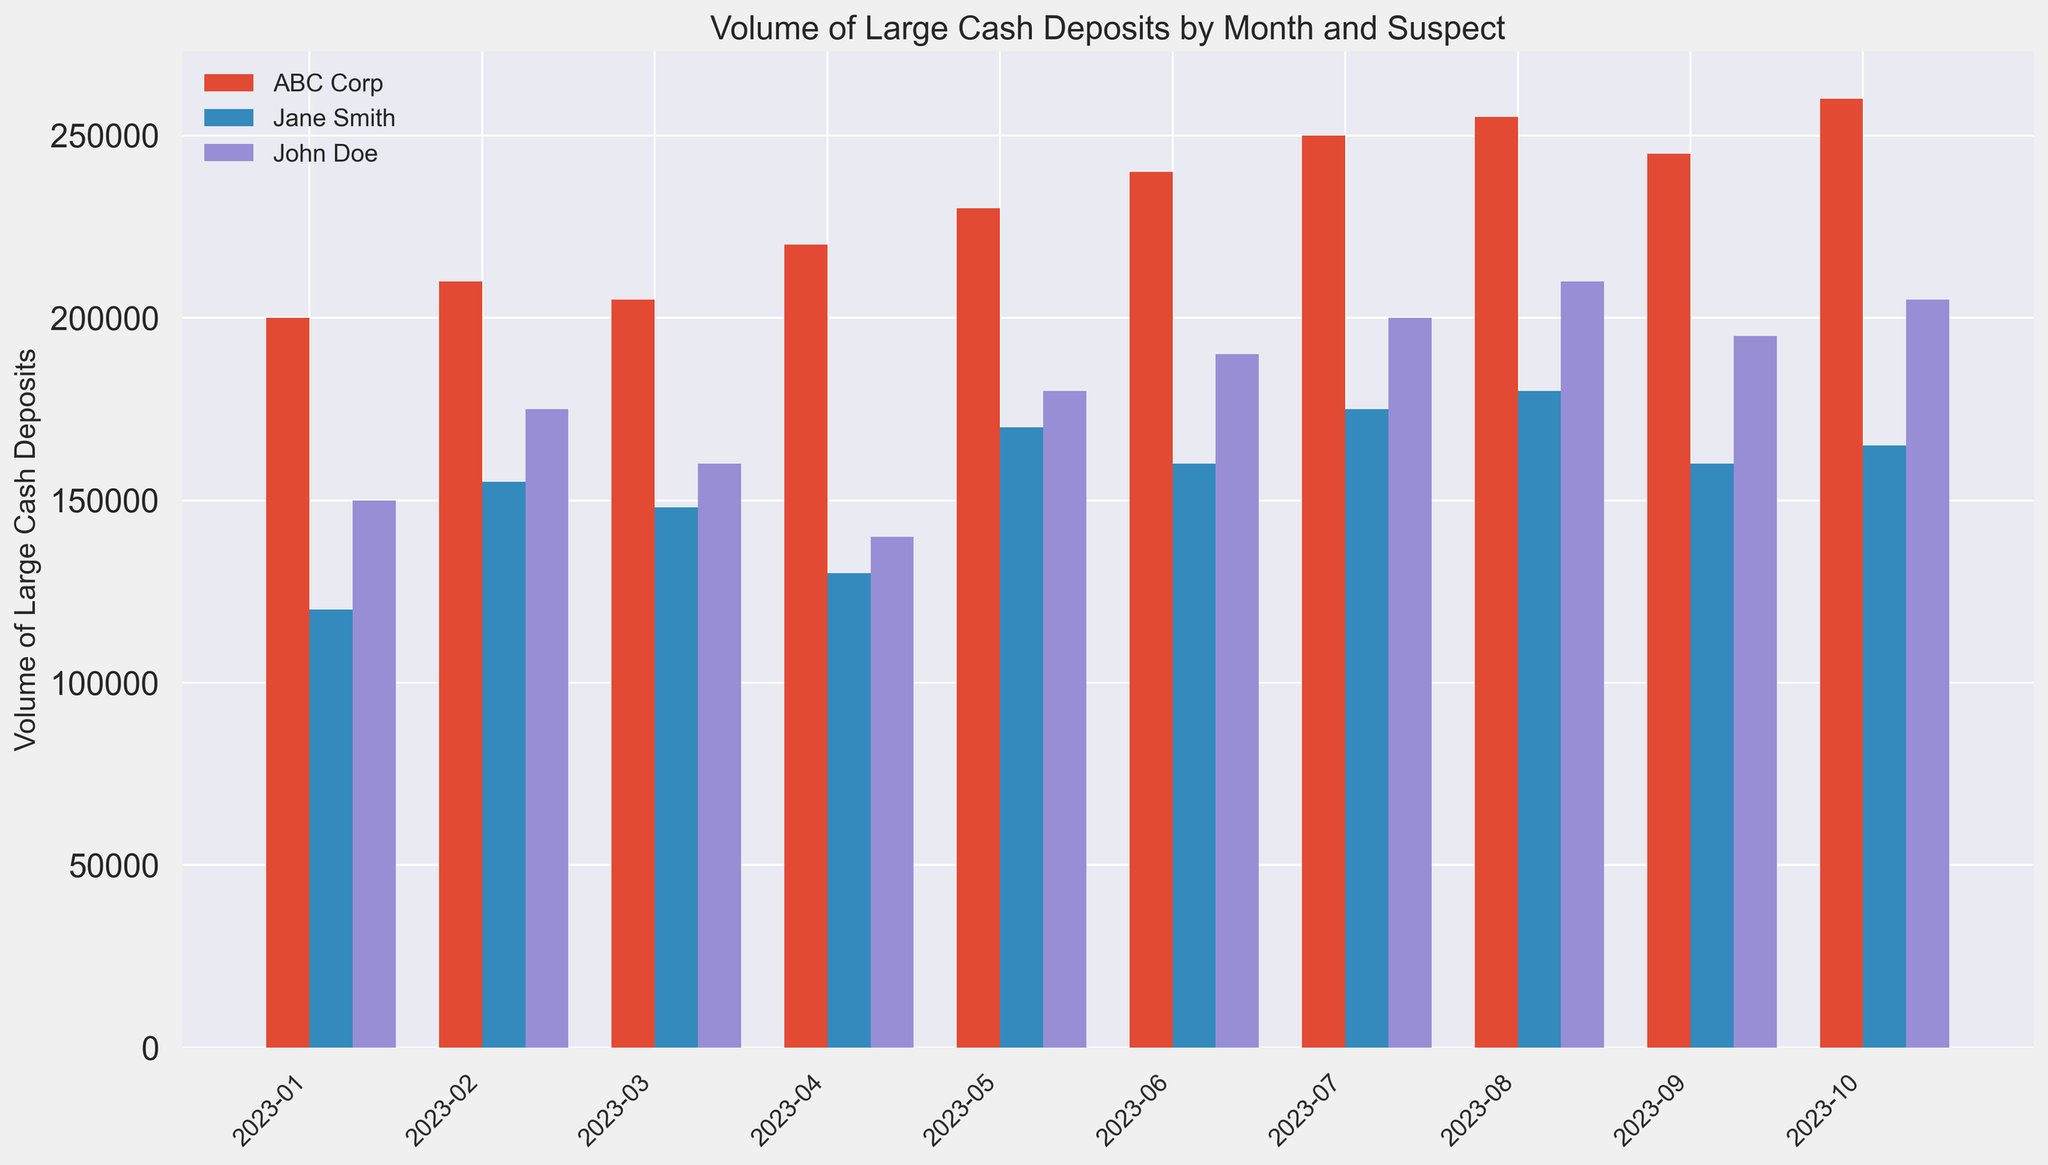Which suspect had the highest volume of large cash deposits in August 2023? From the figure, identify the bars corresponding to August 2023 for each suspect. Compare their heights to find the tallest bar, which represents the highest volume.
Answer: ABC Corp How much more did John Doe deposit in July 2023 compared to April 2023? Locate the bars for John Doe in July 2023 and April 2023. Find their heights and calculate the difference: 200000 (July) - 140000 (April) = 60000.
Answer: 60000 Which months did Jane Smith deposit exactly 160000? Look at the bars for Jane Smith and identify the months where the bar reaches the height of 160000. These months are June 2023 and September 2023.
Answer: June 2023, September 2023 What is the total volume of large cash deposits by ABC Corp in 2023? Sum the heights of the bars for ABC Corp across all months in 2023. The values are 200000, 210000, 205000, 220000, 230000, 240000, 250000, 255000, 245000, 260000. Total is 2315000.
Answer: 2315000 Which suspect has the most consistent deposit volume across all months? Assess the uniformity in the heights of the bars for each suspect. ABC Corp's bars appear the most consistent with less variation compared to others.
Answer: ABC Corp By how much did Jane Smith's deposit volume change from January 2023 to February 2023? Identify the bars for Jane Smith in January 2023 and February 2023. Find their heights and calculate the difference: 155000 (February) - 120000 (January) = 35000.
Answer: 35000 Which month saw the highest combined volume of deposits from all suspects? Sum the heights of the bars for each month. Compare these sums to find the highest one. August 2023 has the highest combined volume (210000 + 180000 + 255000 = 645000).
Answer: August 2023 What is the average monthly deposit volume for John Doe over the given period? Add the heights of the bars for John Doe and divide by the number of months: (150000 + 175000 + 160000 + 140000 + 180000 + 190000 + 200000 + 210000 + 195000 + 205000) / 10 = 180500.
Answer: 180500 Which suspect had the largest increase in deposit volume from one month to the next? Compare month-to-month differences in bar heights for each suspect. The largest increase is John Doe's deposits from January 2023 (150000) to February 2023 (175000), an increase of 25000.
Answer: John Doe 